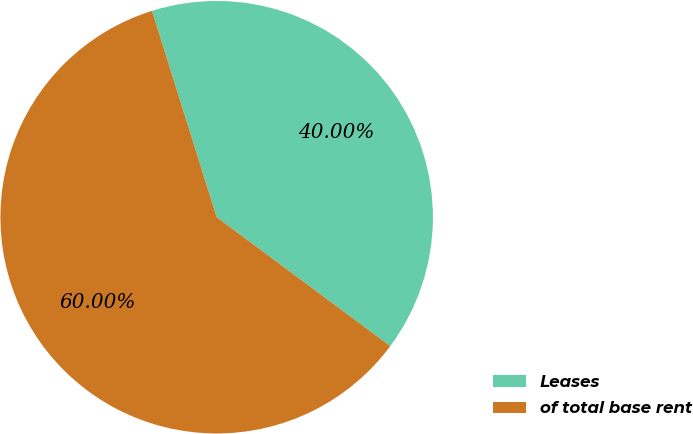Convert chart. <chart><loc_0><loc_0><loc_500><loc_500><pie_chart><fcel>Leases<fcel>of total base rent<nl><fcel>40.0%<fcel>60.0%<nl></chart> 